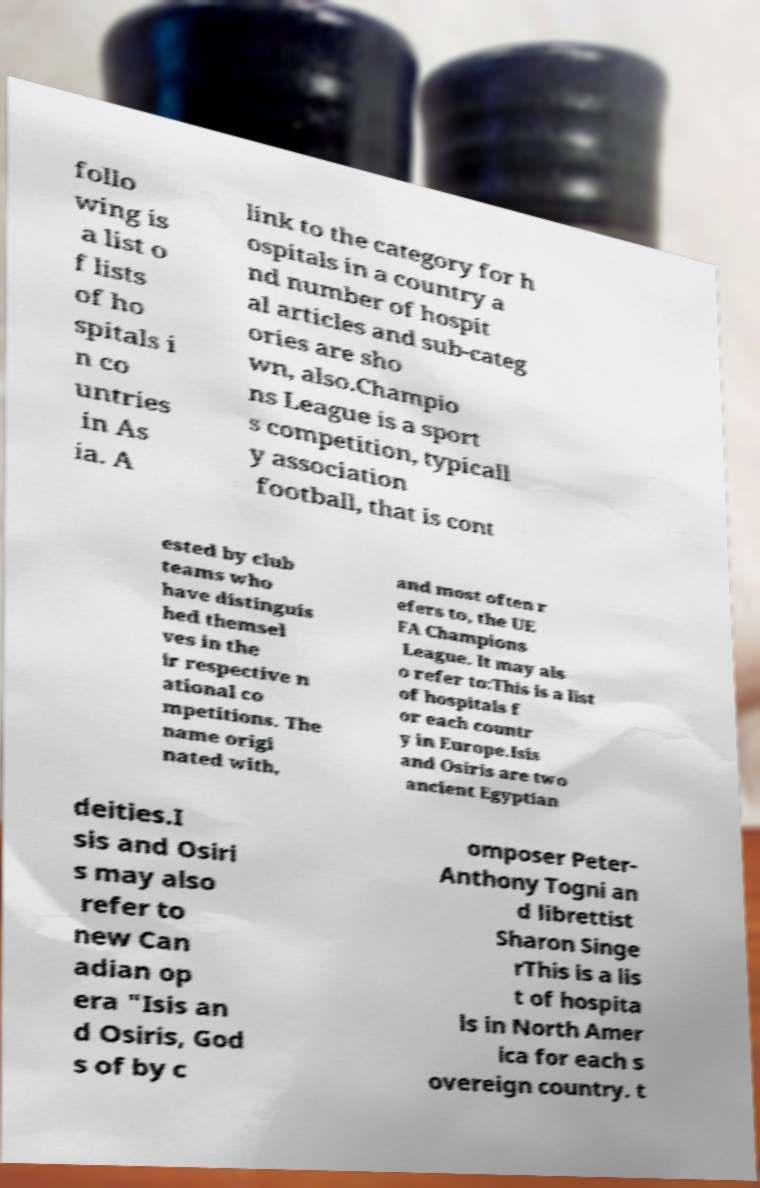Could you extract and type out the text from this image? follo wing is a list o f lists of ho spitals i n co untries in As ia. A link to the category for h ospitals in a country a nd number of hospit al articles and sub-categ ories are sho wn, also.Champio ns League is a sport s competition, typicall y association football, that is cont ested by club teams who have distinguis hed themsel ves in the ir respective n ational co mpetitions. The name origi nated with, and most often r efers to, the UE FA Champions League. It may als o refer to:This is a list of hospitals f or each countr y in Europe.Isis and Osiris are two ancient Egyptian deities.I sis and Osiri s may also refer to new Can adian op era "Isis an d Osiris, God s of by c omposer Peter- Anthony Togni an d librettist Sharon Singe rThis is a lis t of hospita ls in North Amer ica for each s overeign country. t 